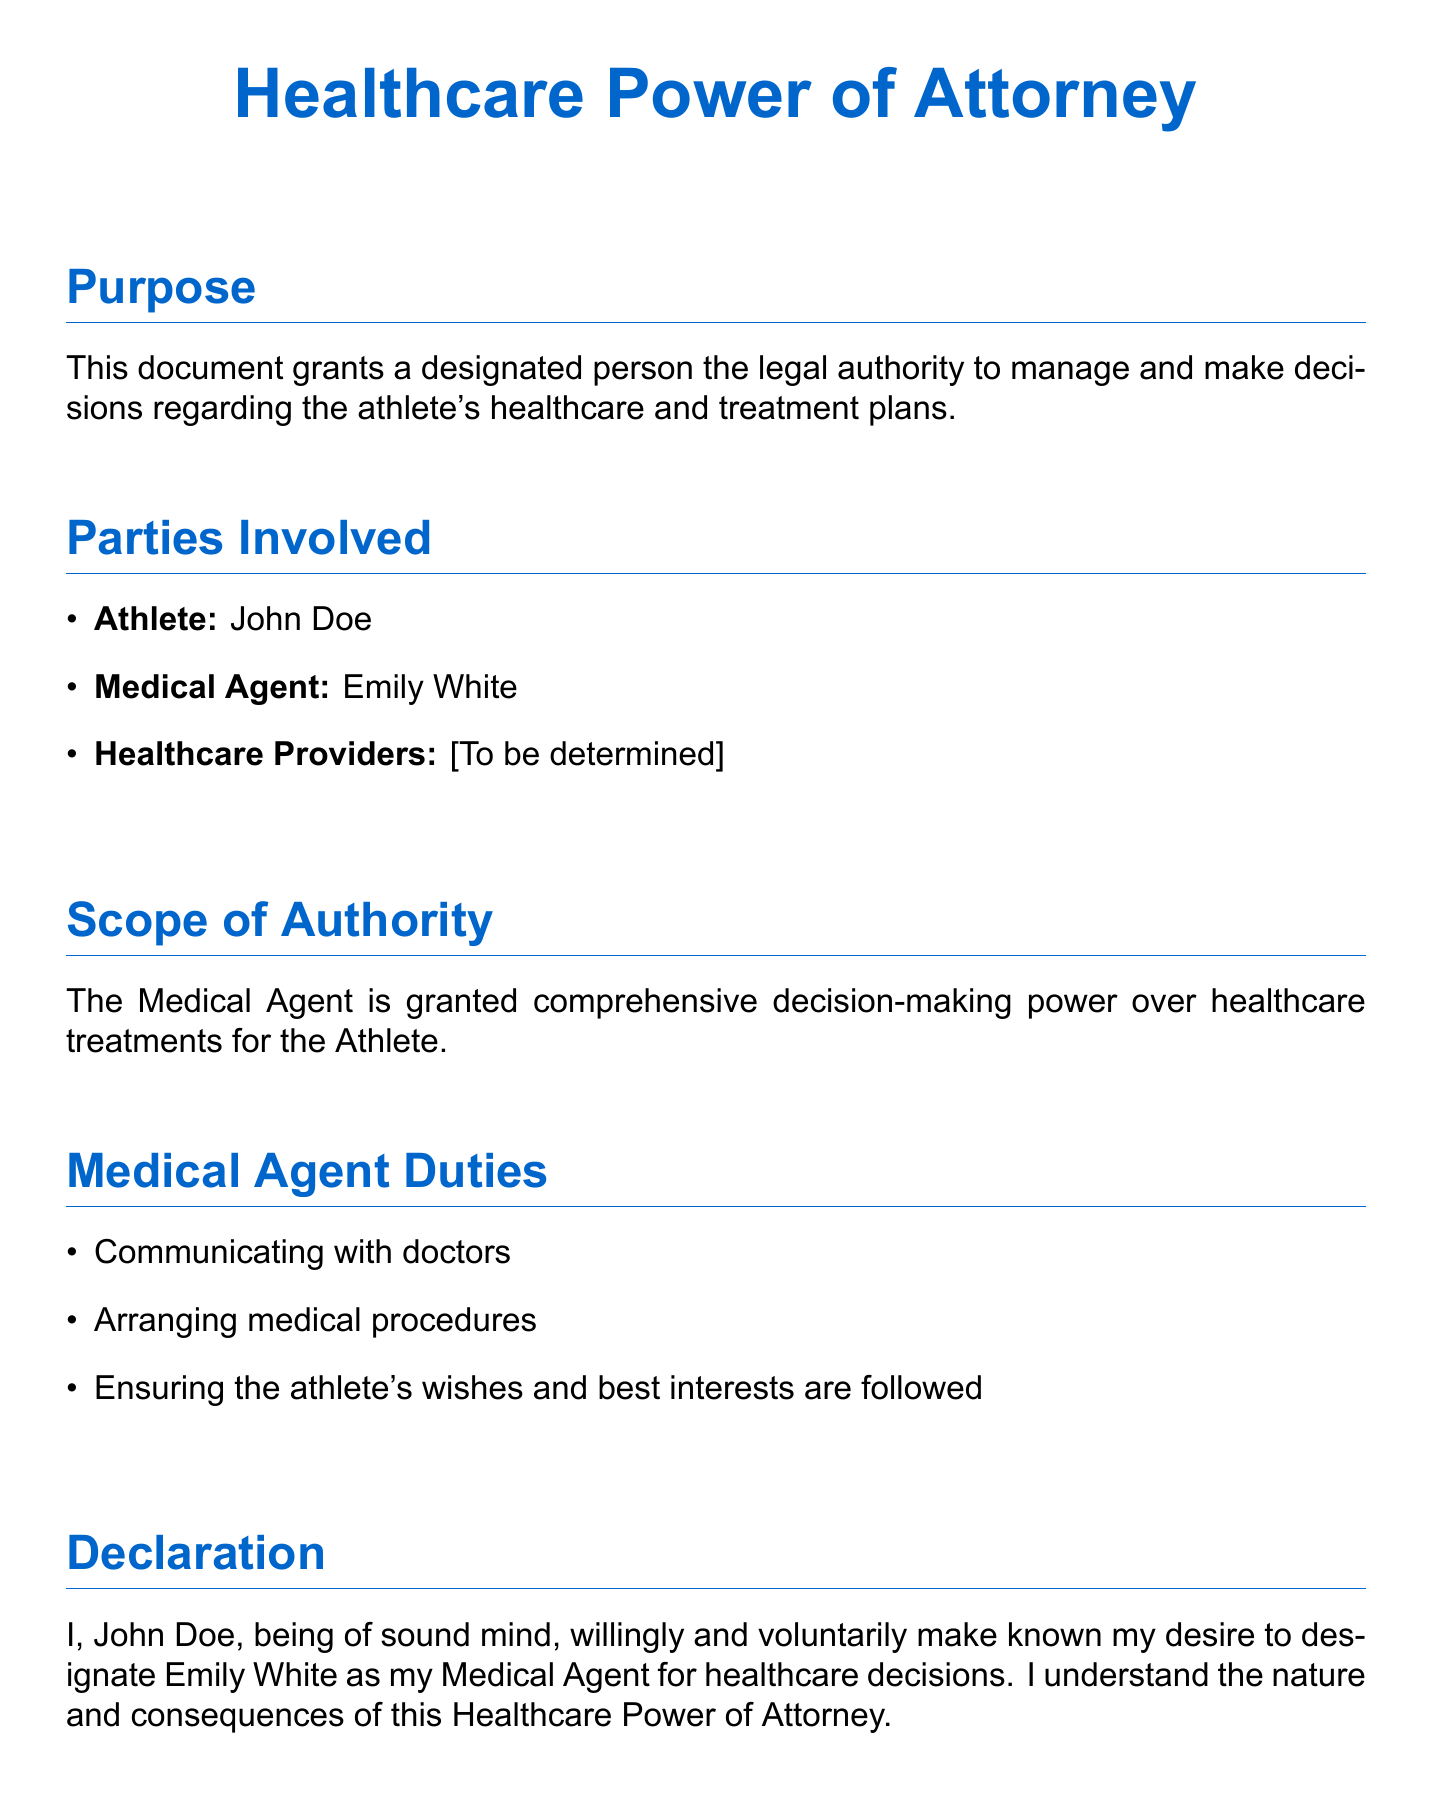What is the purpose of this document? The purpose is to grant a designated person the legal authority to manage and make decisions regarding the athlete's healthcare and treatment plans.
Answer: Grant authority for healthcare decisions Who is the athlete named in the document? The athlete's name is specified at the beginning of the document under the parties involved section.
Answer: John Doe Who is designated as the Medical Agent? The Medical Agent is the person assigned to make healthcare decisions for the athlete as stated in the parties involved section.
Answer: Emily White What are two duties of the Medical Agent? The duties are listed in the Medical Agent Duties section.
Answer: Communicating with doctors, Arranging medical procedures What must the athlete's signature indicate? The signature must indicate the athlete's consent and understanding of the document's implications regarding the designation of a Medical Agent.
Answer: Consent and understanding How many signatures are required for this document to be valid? The document includes a section for signatures, indicating multiple individuals must sign.
Answer: Three signatures 